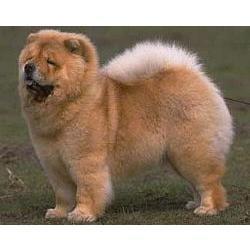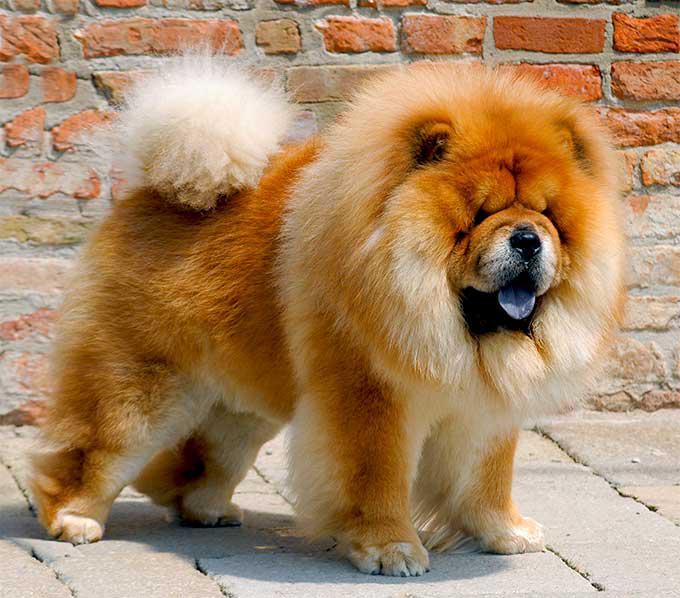The first image is the image on the left, the second image is the image on the right. Analyze the images presented: Is the assertion "There are three animals" valid? Answer yes or no. No. The first image is the image on the left, the second image is the image on the right. Given the left and right images, does the statement "The dog in the right image is looking towards the right." hold true? Answer yes or no. Yes. The first image is the image on the left, the second image is the image on the right. For the images displayed, is the sentence "Exactly two dogs can be seen to be standing, and have their white tails curled up and laying on their backs" factually correct? Answer yes or no. Yes. 